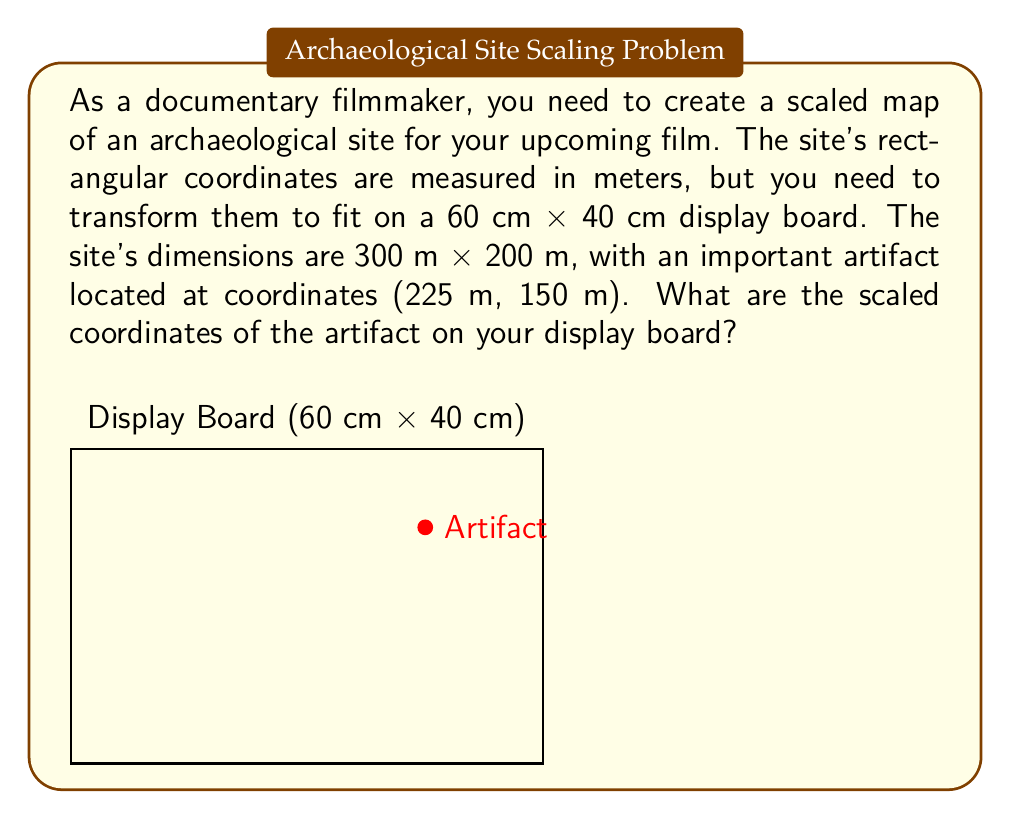Solve this math problem. To solve this problem, we need to follow these steps:

1) First, let's determine the scale factor. We need to fit 300 m into 60 cm and 200 m into 40 cm.

   Scale factor for x-axis: $\frac{60 \text{ cm}}{300 \text{ m}} = 0.2 \text{ cm/m}$
   Scale factor for y-axis: $\frac{40 \text{ cm}}{200 \text{ m}} = 0.2 \text{ cm/m}$

   Both scale factors are the same, which means our map will be proportional.

2) Now, we can use this scale factor to transform the artifact's coordinates:

   x-coordinate: $225 \text{ m} \times 0.2 \text{ cm/m} = 45 \text{ cm}$
   y-coordinate: $150 \text{ m} \times 0.2 \text{ cm/m} = 30 \text{ cm}$

3) Therefore, on our display board, the artifact will be located at (45 cm, 30 cm).

4) To verify:
   - The x-coordinate (45 cm) is 75% of the board's width (60 cm), which corresponds to 225 m being 75% of 300 m.
   - The y-coordinate (30 cm) is 75% of the board's height (40 cm), which corresponds to 150 m being 75% of 200 m.

This confirms that our scaling is correct and proportional.
Answer: (45 cm, 30 cm) 